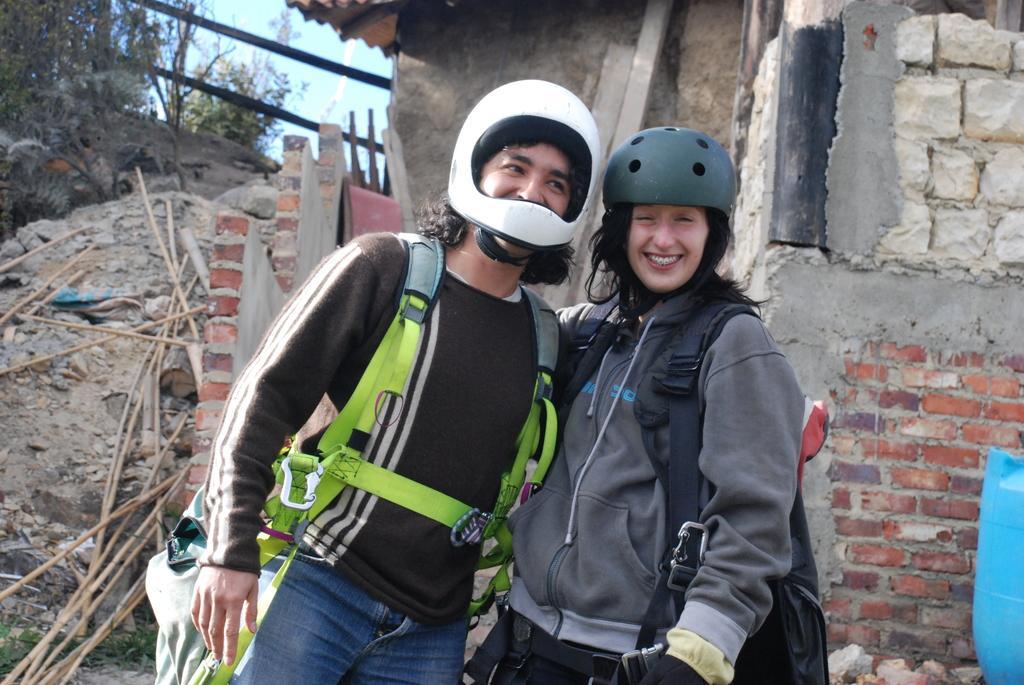Can you describe this image briefly? In the picture I can see man and woman wearing helmets, carrying bags standing and posing for a photograph and in the background there is a house, there are some trees and clear sky. 